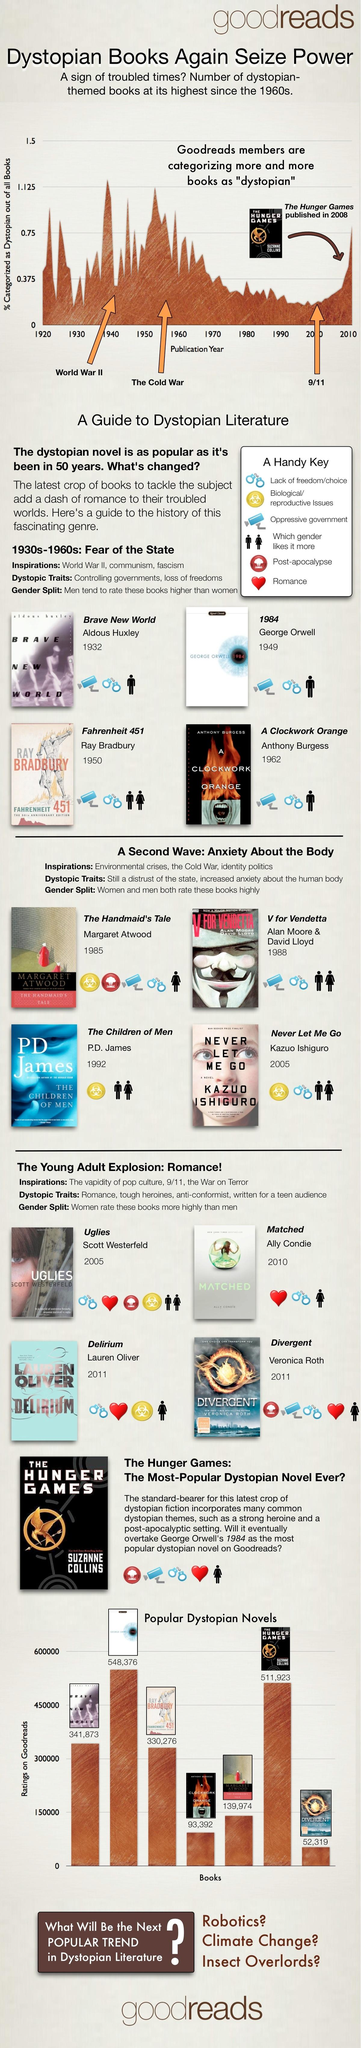Identify some key points in this picture. Ray Bradbury is the author of "Fahrenheit 451. 1984 is the dystopian novel with the highest rating on Goodreads. According to Goodreads, the rating for the novel "Brave New World" is 341,873. The novel titled '1984' was published in 1949. Ally Condie is the author of 'Matched.' 